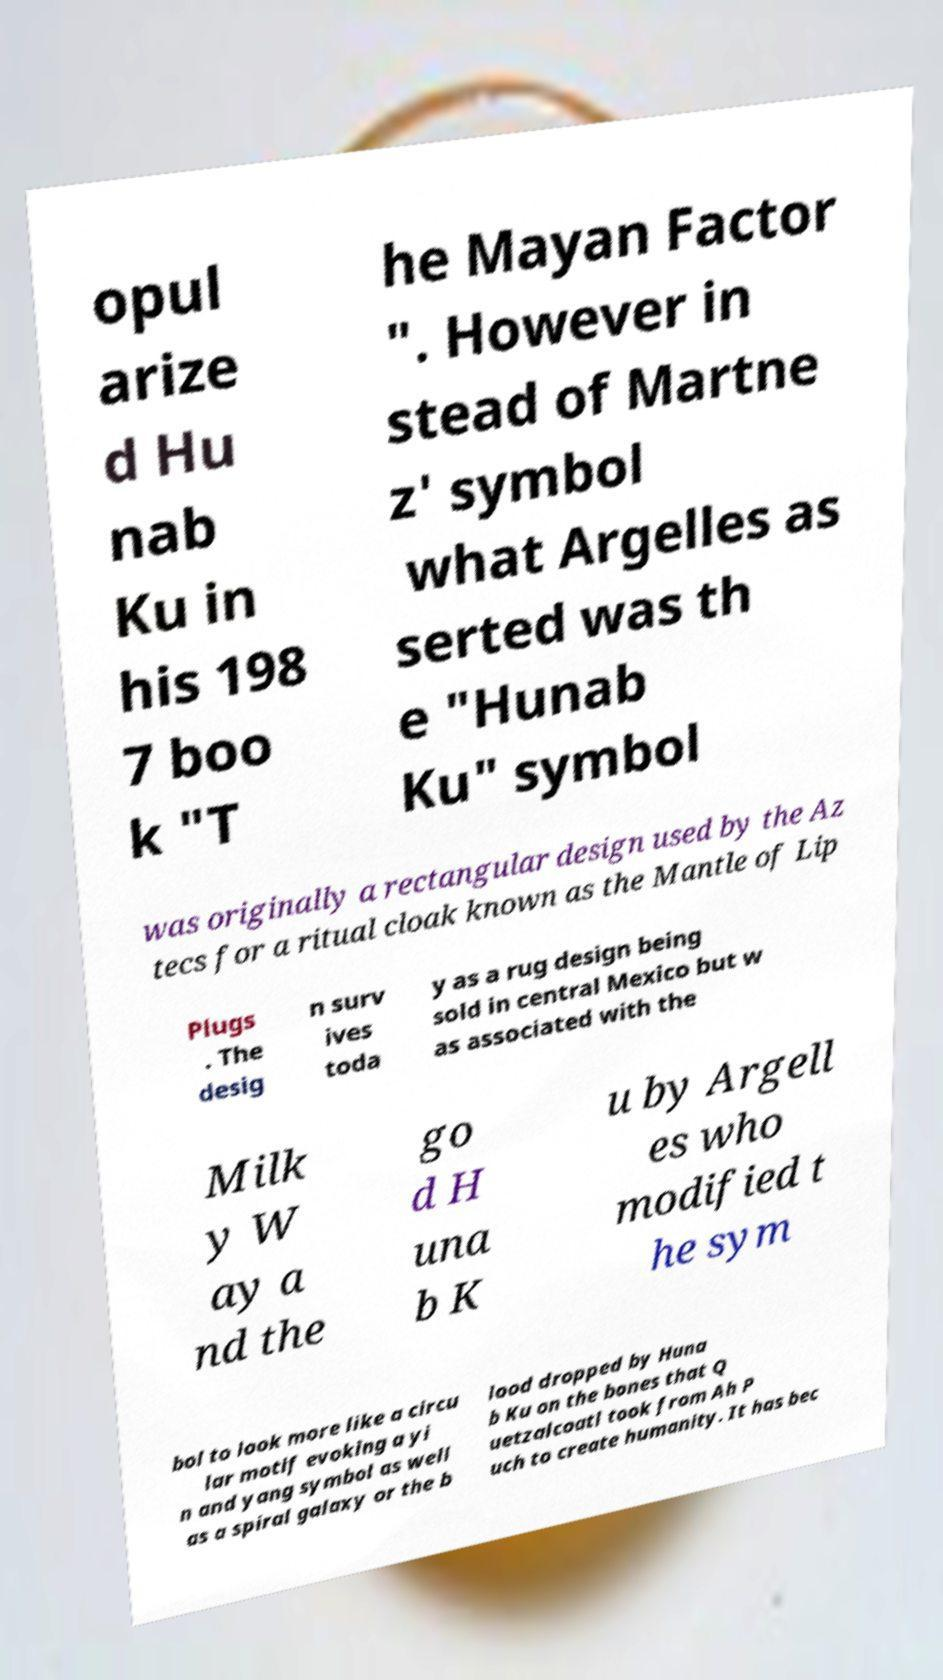Please read and relay the text visible in this image. What does it say? opul arize d Hu nab Ku in his 198 7 boo k "T he Mayan Factor ". However in stead of Martne z' symbol what Argelles as serted was th e "Hunab Ku" symbol was originally a rectangular design used by the Az tecs for a ritual cloak known as the Mantle of Lip Plugs . The desig n surv ives toda y as a rug design being sold in central Mexico but w as associated with the Milk y W ay a nd the go d H una b K u by Argell es who modified t he sym bol to look more like a circu lar motif evoking a yi n and yang symbol as well as a spiral galaxy or the b lood dropped by Huna b Ku on the bones that Q uetzalcoatl took from Ah P uch to create humanity. It has bec 